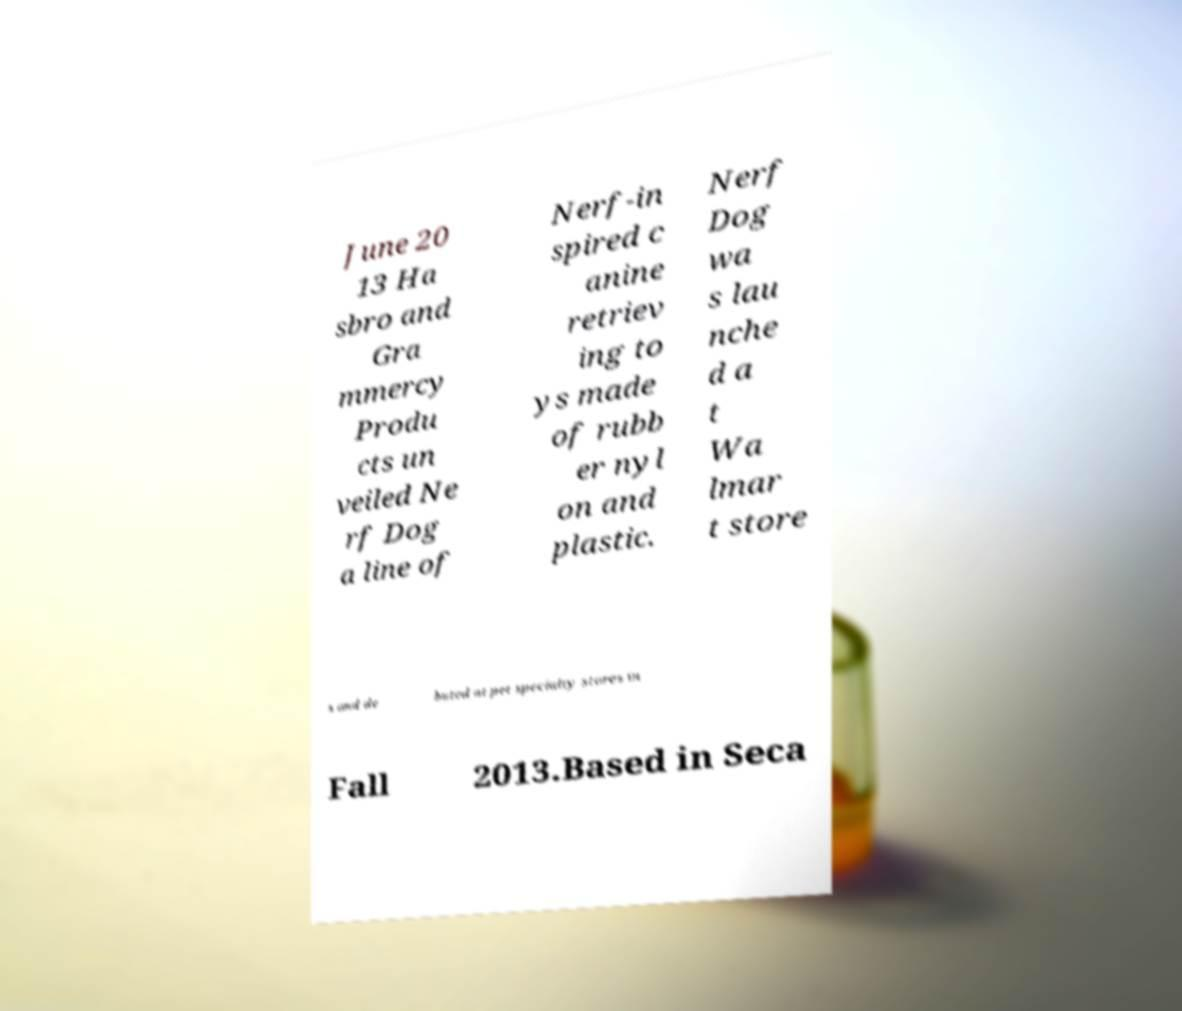There's text embedded in this image that I need extracted. Can you transcribe it verbatim? June 20 13 Ha sbro and Gra mmercy Produ cts un veiled Ne rf Dog a line of Nerf-in spired c anine retriev ing to ys made of rubb er nyl on and plastic. Nerf Dog wa s lau nche d a t Wa lmar t store s and de buted at pet specialty stores in Fall 2013.Based in Seca 